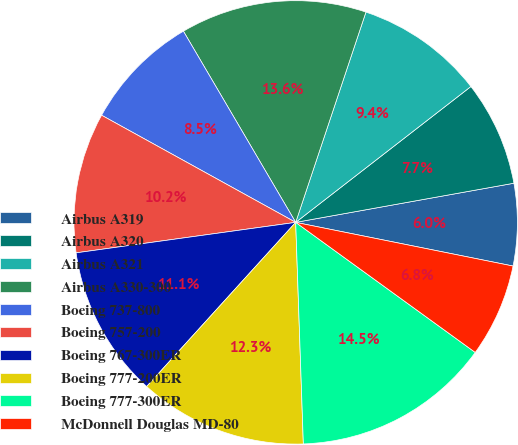<chart> <loc_0><loc_0><loc_500><loc_500><pie_chart><fcel>Airbus A319<fcel>Airbus A320<fcel>Airbus A321<fcel>Airbus A330-300<fcel>Boeing 737-800<fcel>Boeing 757-200<fcel>Boeing 767-300ER<fcel>Boeing 777-200ER<fcel>Boeing 777-300ER<fcel>McDonnell Douglas MD-80<nl><fcel>5.98%<fcel>7.67%<fcel>9.37%<fcel>13.58%<fcel>8.52%<fcel>10.22%<fcel>11.07%<fcel>12.28%<fcel>14.47%<fcel>6.82%<nl></chart> 